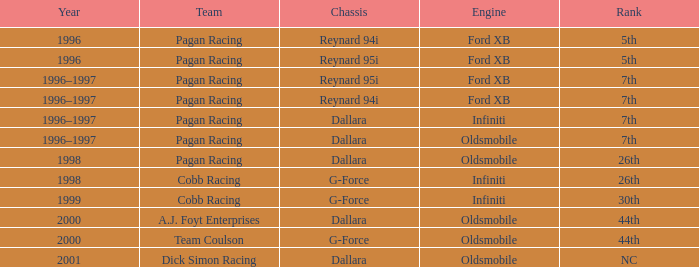What engine was used in 1999? Infiniti. 